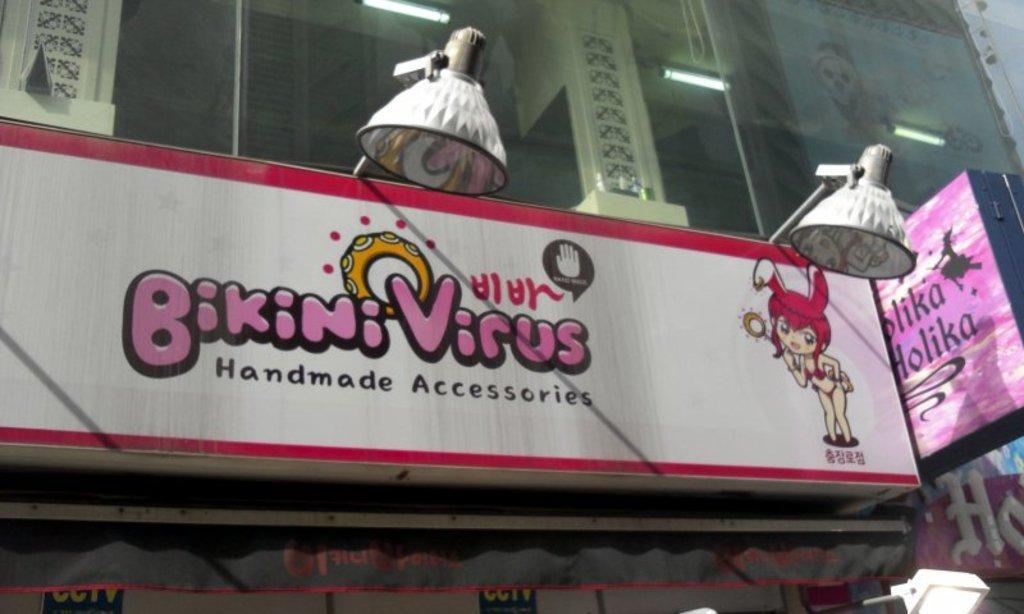Describe this image in one or two sentences. In the center of the image there is a glass, lights, hanging lamps, boards with some text and a few other objects. 